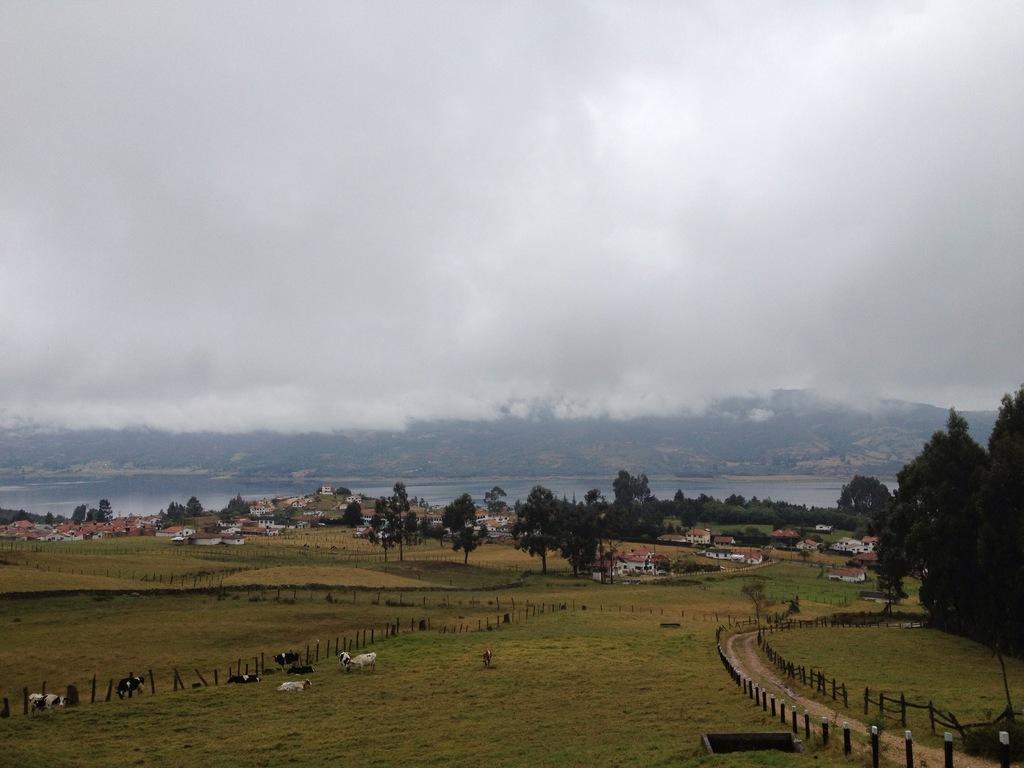How would you summarize this image in a sentence or two? In the picture we can see animals on the grass, we can see the fence, road, houses, trees, water, hills and the cloudy sky in the background. 